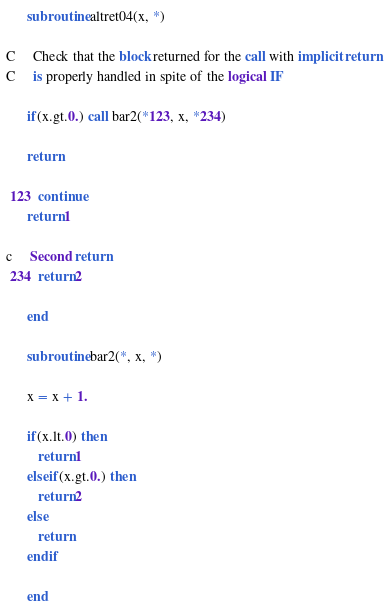<code> <loc_0><loc_0><loc_500><loc_500><_FORTRAN_>      subroutine altret04(x, *)

C     Check that the block returned for the call with implicit return
C     is properly handled in spite of the logical IF

      if(x.gt.0.) call bar2(*123, x, *234)

      return

 123  continue
      return 1

c     Second return
 234  return 2

      end

      subroutine bar2(*, x, *)

      x = x + 1.

      if(x.lt.0) then  
         return 1
      elseif(x.gt.0.) then 
         return 2
      else 
         return
      endif

      end
</code> 